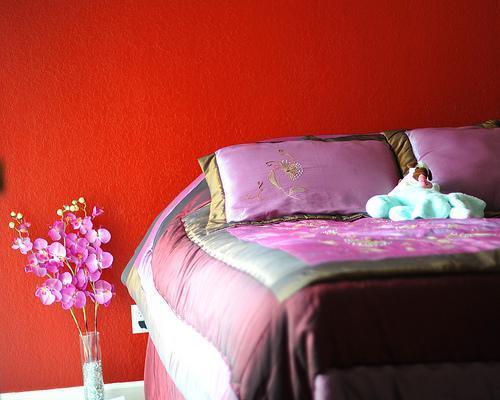How many pilows are on the bed?
Give a very brief answer. 2. 